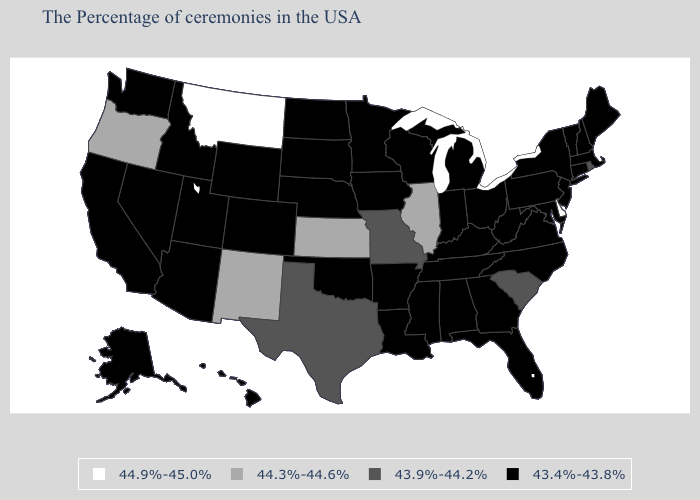Which states hav the highest value in the Northeast?
Keep it brief. Rhode Island. What is the lowest value in states that border Kentucky?
Quick response, please. 43.4%-43.8%. Does Kansas have the highest value in the MidWest?
Write a very short answer. Yes. What is the lowest value in the USA?
Write a very short answer. 43.4%-43.8%. Name the states that have a value in the range 44.3%-44.6%?
Short answer required. Illinois, Kansas, New Mexico, Oregon. What is the value of Texas?
Write a very short answer. 43.9%-44.2%. Name the states that have a value in the range 43.9%-44.2%?
Concise answer only. Rhode Island, South Carolina, Missouri, Texas. What is the value of Indiana?
Answer briefly. 43.4%-43.8%. What is the value of Hawaii?
Short answer required. 43.4%-43.8%. Which states hav the highest value in the MidWest?
Answer briefly. Illinois, Kansas. Does Delaware have the highest value in the USA?
Short answer required. Yes. Among the states that border Arizona , does Utah have the highest value?
Give a very brief answer. No. Does California have the lowest value in the USA?
Give a very brief answer. Yes. Does Idaho have a lower value than Iowa?
Write a very short answer. No. What is the value of South Dakota?
Write a very short answer. 43.4%-43.8%. 